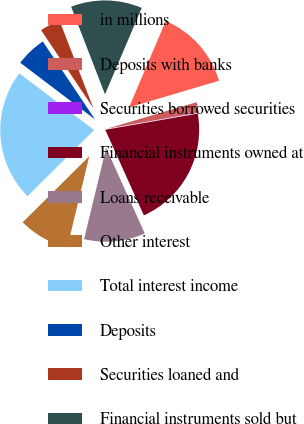Convert chart. <chart><loc_0><loc_0><loc_500><loc_500><pie_chart><fcel>in millions<fcel>Deposits with banks<fcel>Securities borrowed securities<fcel>Financial instruments owned at<fcel>Loans receivable<fcel>Other interest<fcel>Total interest income<fcel>Deposits<fcel>Securities loaned and<fcel>Financial instruments sold but<nl><fcel>14.02%<fcel>1.78%<fcel>0.04%<fcel>21.01%<fcel>10.52%<fcel>8.78%<fcel>22.76%<fcel>5.28%<fcel>3.53%<fcel>12.27%<nl></chart> 